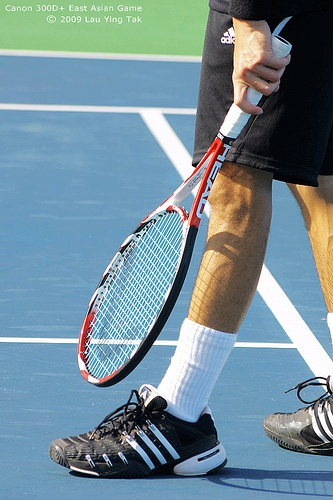Describe the objects in this image and their specific colors. I can see people in lightgreen, black, gray, white, and tan tones and tennis racket in lightgreen, white, black, gray, and lightblue tones in this image. 